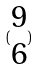Convert formula to latex. <formula><loc_0><loc_0><loc_500><loc_500>( \begin{matrix} 9 \\ 6 \end{matrix} )</formula> 